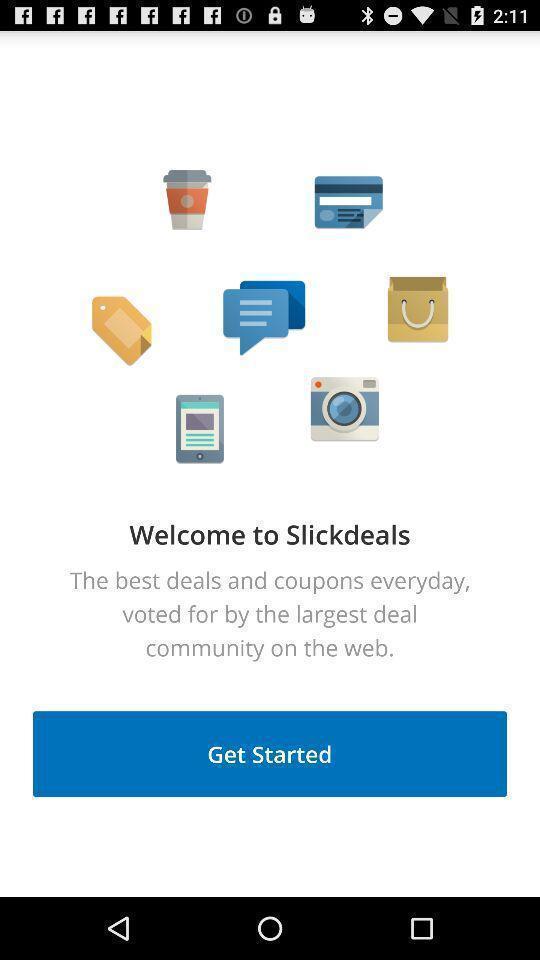What is the overall content of this screenshot? Welcome page of the application get started tab. 